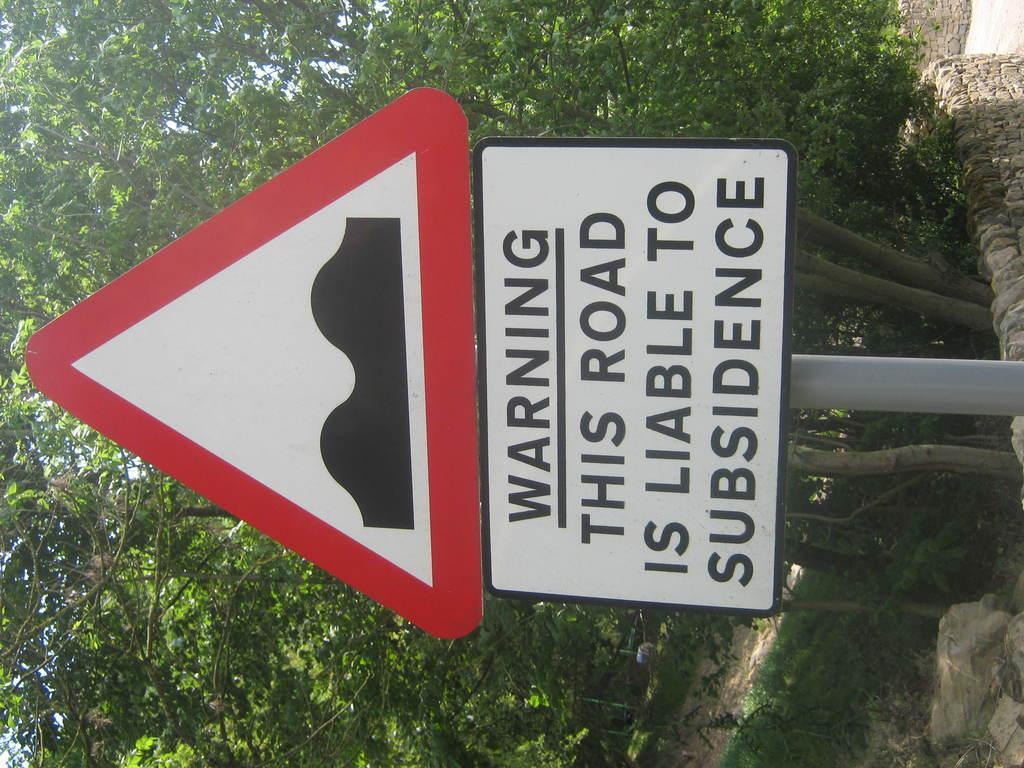Describe this image in one or two sentences. In this image we can see a sign board and texts written on the other board on a pole. In the background we can see trees, grass on the ground and walls. 